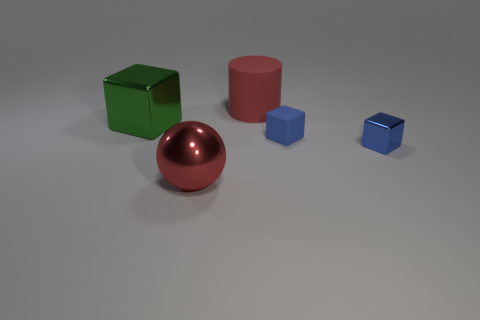Subtract all blue cylinders. How many blue cubes are left? 2 Subtract all large blocks. How many blocks are left? 2 Add 3 large cyan matte cylinders. How many objects exist? 8 Subtract all spheres. How many objects are left? 4 Subtract all cyan cubes. Subtract all green spheres. How many cubes are left? 3 Add 5 small purple blocks. How many small purple blocks exist? 5 Subtract 1 red cylinders. How many objects are left? 4 Subtract all cyan cubes. Subtract all metal blocks. How many objects are left? 3 Add 3 blue cubes. How many blue cubes are left? 5 